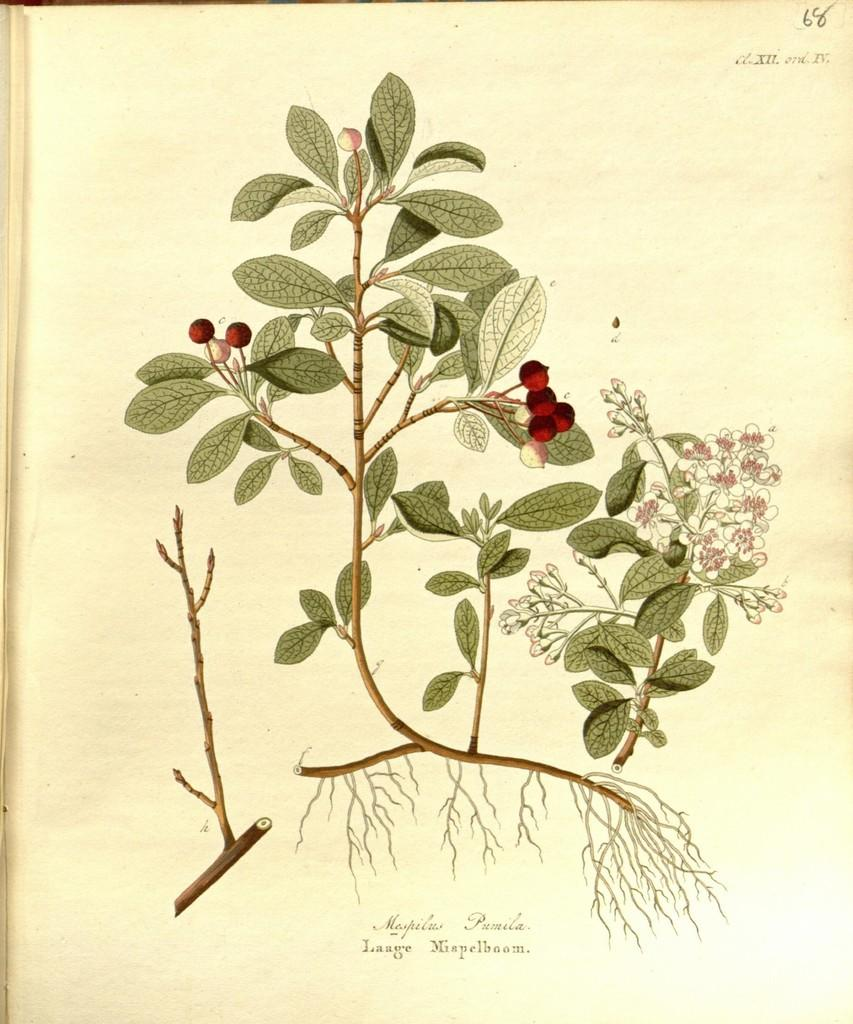What is depicted on the paper in the image? The paper contains a picture of a plant. What features of the plant can be seen in the image? The plant has leaves, fruits, and flowers. Are there any words on the paper? Yes, there are words on the paper. Are there any numbers on the paper? Yes, there are numbers on the paper. What type of crayon is being used to draw the plant on the paper? There is no crayon present in the image; the plant is depicted in a picture on the paper. What color is the ink used to write the words on the paper? There is no mention of ink or color in the image, as the focus is on the paper and the plant depicted on it. 